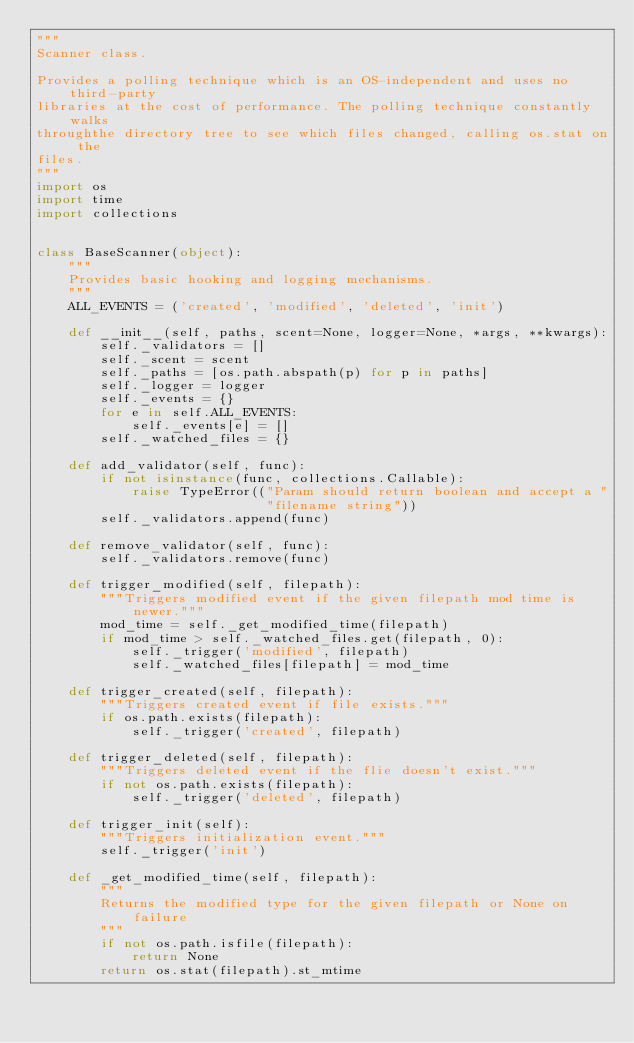Convert code to text. <code><loc_0><loc_0><loc_500><loc_500><_Python_>"""
Scanner class.

Provides a polling technique which is an OS-independent and uses no third-party
libraries at the cost of performance. The polling technique constantly walks
throughthe directory tree to see which files changed, calling os.stat on the
files.
"""
import os
import time
import collections


class BaseScanner(object):
    """
    Provides basic hooking and logging mechanisms.
    """
    ALL_EVENTS = ('created', 'modified', 'deleted', 'init')

    def __init__(self, paths, scent=None, logger=None, *args, **kwargs):
        self._validators = []
        self._scent = scent
        self._paths = [os.path.abspath(p) for p in paths]
        self._logger = logger
        self._events = {}
        for e in self.ALL_EVENTS:
            self._events[e] = []
        self._watched_files = {}

    def add_validator(self, func):
        if not isinstance(func, collections.Callable):
            raise TypeError(("Param should return boolean and accept a "
                             "filename string"))
        self._validators.append(func)

    def remove_validator(self, func):
        self._validators.remove(func)

    def trigger_modified(self, filepath):
        """Triggers modified event if the given filepath mod time is newer."""
        mod_time = self._get_modified_time(filepath)
        if mod_time > self._watched_files.get(filepath, 0):
            self._trigger('modified', filepath)
            self._watched_files[filepath] = mod_time

    def trigger_created(self, filepath):
        """Triggers created event if file exists."""
        if os.path.exists(filepath):
            self._trigger('created', filepath)

    def trigger_deleted(self, filepath):
        """Triggers deleted event if the flie doesn't exist."""
        if not os.path.exists(filepath):
            self._trigger('deleted', filepath)

    def trigger_init(self):
        """Triggers initialization event."""
        self._trigger('init')

    def _get_modified_time(self, filepath):
        """
        Returns the modified type for the given filepath or None on failure
        """
        if not os.path.isfile(filepath):
            return None
        return os.stat(filepath).st_mtime
</code> 